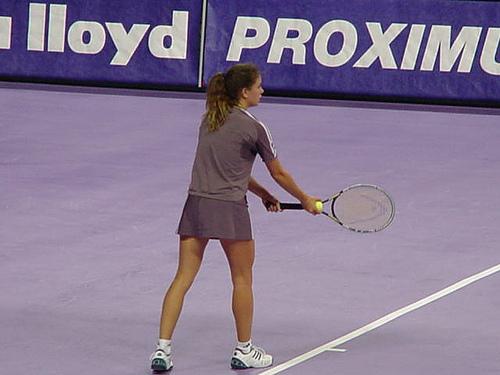What sport is the woman playing?
Be succinct. Tennis. Are they indoors?
Quick response, please. Yes. What color is the round object in the woman's hand?
Quick response, please. Yellow. Is the player wearing shorts?
Keep it brief. No. 